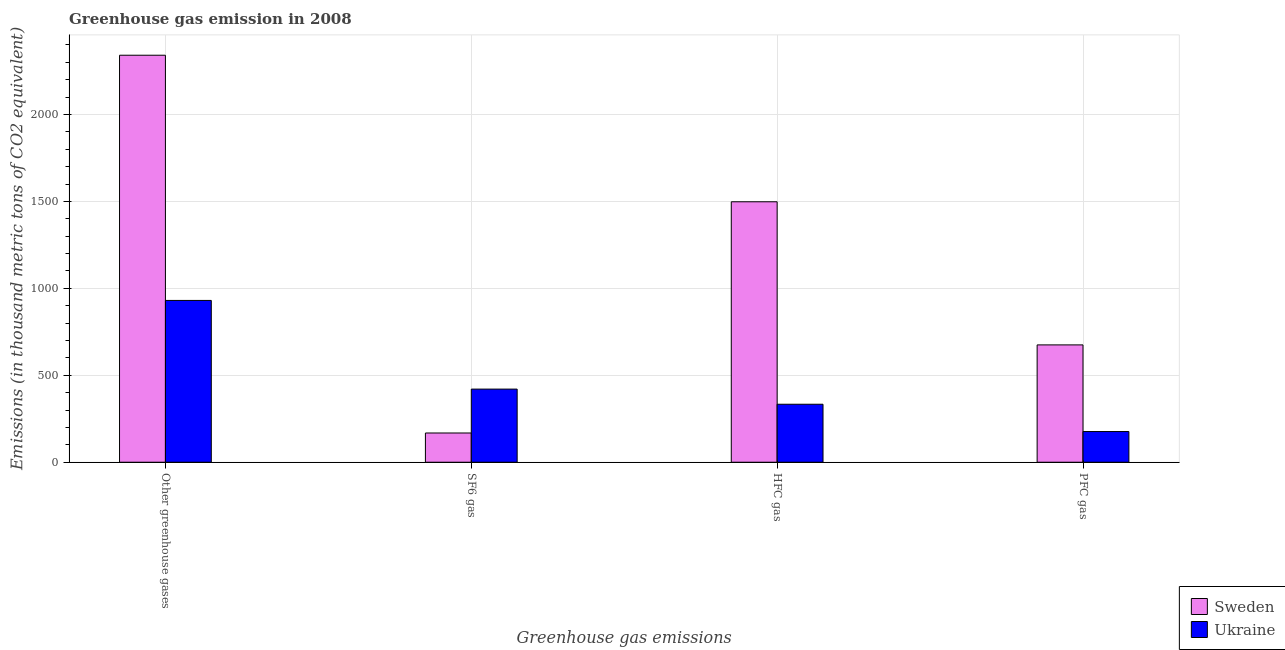How many groups of bars are there?
Your response must be concise. 4. Are the number of bars per tick equal to the number of legend labels?
Your response must be concise. Yes. How many bars are there on the 1st tick from the left?
Offer a terse response. 2. How many bars are there on the 3rd tick from the right?
Keep it short and to the point. 2. What is the label of the 4th group of bars from the left?
Make the answer very short. PFC gas. What is the emission of sf6 gas in Sweden?
Provide a succinct answer. 168.1. Across all countries, what is the maximum emission of pfc gas?
Your answer should be compact. 674.8. Across all countries, what is the minimum emission of greenhouse gases?
Ensure brevity in your answer.  930.6. In which country was the emission of pfc gas minimum?
Ensure brevity in your answer.  Ukraine. What is the total emission of greenhouse gases in the graph?
Ensure brevity in your answer.  3271.5. What is the difference between the emission of pfc gas in Sweden and that in Ukraine?
Offer a terse response. 498.3. What is the difference between the emission of pfc gas in Sweden and the emission of sf6 gas in Ukraine?
Your response must be concise. 254.2. What is the average emission of greenhouse gases per country?
Your response must be concise. 1635.75. What is the difference between the emission of hfc gas and emission of greenhouse gases in Sweden?
Your answer should be very brief. -842.9. In how many countries, is the emission of sf6 gas greater than 1000 thousand metric tons?
Your answer should be compact. 0. What is the ratio of the emission of hfc gas in Ukraine to that in Sweden?
Offer a very short reply. 0.22. Is the emission of pfc gas in Ukraine less than that in Sweden?
Give a very brief answer. Yes. Is the difference between the emission of greenhouse gases in Sweden and Ukraine greater than the difference between the emission of hfc gas in Sweden and Ukraine?
Provide a short and direct response. Yes. What is the difference between the highest and the second highest emission of hfc gas?
Your response must be concise. 1164.5. What is the difference between the highest and the lowest emission of sf6 gas?
Ensure brevity in your answer.  252.5. In how many countries, is the emission of hfc gas greater than the average emission of hfc gas taken over all countries?
Keep it short and to the point. 1. Is the sum of the emission of pfc gas in Sweden and Ukraine greater than the maximum emission of greenhouse gases across all countries?
Your response must be concise. No. Is it the case that in every country, the sum of the emission of greenhouse gases and emission of hfc gas is greater than the sum of emission of sf6 gas and emission of pfc gas?
Ensure brevity in your answer.  No. What does the 1st bar from the right in SF6 gas represents?
Ensure brevity in your answer.  Ukraine. Is it the case that in every country, the sum of the emission of greenhouse gases and emission of sf6 gas is greater than the emission of hfc gas?
Provide a succinct answer. Yes. Are all the bars in the graph horizontal?
Make the answer very short. No. How many countries are there in the graph?
Keep it short and to the point. 2. What is the difference between two consecutive major ticks on the Y-axis?
Keep it short and to the point. 500. Are the values on the major ticks of Y-axis written in scientific E-notation?
Your response must be concise. No. How many legend labels are there?
Offer a terse response. 2. How are the legend labels stacked?
Your response must be concise. Vertical. What is the title of the graph?
Ensure brevity in your answer.  Greenhouse gas emission in 2008. What is the label or title of the X-axis?
Your answer should be compact. Greenhouse gas emissions. What is the label or title of the Y-axis?
Provide a short and direct response. Emissions (in thousand metric tons of CO2 equivalent). What is the Emissions (in thousand metric tons of CO2 equivalent) of Sweden in Other greenhouse gases?
Keep it short and to the point. 2340.9. What is the Emissions (in thousand metric tons of CO2 equivalent) in Ukraine in Other greenhouse gases?
Give a very brief answer. 930.6. What is the Emissions (in thousand metric tons of CO2 equivalent) of Sweden in SF6 gas?
Your answer should be compact. 168.1. What is the Emissions (in thousand metric tons of CO2 equivalent) in Ukraine in SF6 gas?
Offer a very short reply. 420.6. What is the Emissions (in thousand metric tons of CO2 equivalent) in Sweden in HFC gas?
Give a very brief answer. 1498. What is the Emissions (in thousand metric tons of CO2 equivalent) in Ukraine in HFC gas?
Offer a very short reply. 333.5. What is the Emissions (in thousand metric tons of CO2 equivalent) of Sweden in PFC gas?
Ensure brevity in your answer.  674.8. What is the Emissions (in thousand metric tons of CO2 equivalent) in Ukraine in PFC gas?
Make the answer very short. 176.5. Across all Greenhouse gas emissions, what is the maximum Emissions (in thousand metric tons of CO2 equivalent) of Sweden?
Your answer should be compact. 2340.9. Across all Greenhouse gas emissions, what is the maximum Emissions (in thousand metric tons of CO2 equivalent) of Ukraine?
Offer a terse response. 930.6. Across all Greenhouse gas emissions, what is the minimum Emissions (in thousand metric tons of CO2 equivalent) in Sweden?
Provide a short and direct response. 168.1. Across all Greenhouse gas emissions, what is the minimum Emissions (in thousand metric tons of CO2 equivalent) in Ukraine?
Your answer should be compact. 176.5. What is the total Emissions (in thousand metric tons of CO2 equivalent) of Sweden in the graph?
Keep it short and to the point. 4681.8. What is the total Emissions (in thousand metric tons of CO2 equivalent) in Ukraine in the graph?
Give a very brief answer. 1861.2. What is the difference between the Emissions (in thousand metric tons of CO2 equivalent) of Sweden in Other greenhouse gases and that in SF6 gas?
Your answer should be compact. 2172.8. What is the difference between the Emissions (in thousand metric tons of CO2 equivalent) in Ukraine in Other greenhouse gases and that in SF6 gas?
Your answer should be very brief. 510. What is the difference between the Emissions (in thousand metric tons of CO2 equivalent) in Sweden in Other greenhouse gases and that in HFC gas?
Provide a short and direct response. 842.9. What is the difference between the Emissions (in thousand metric tons of CO2 equivalent) in Ukraine in Other greenhouse gases and that in HFC gas?
Keep it short and to the point. 597.1. What is the difference between the Emissions (in thousand metric tons of CO2 equivalent) in Sweden in Other greenhouse gases and that in PFC gas?
Make the answer very short. 1666.1. What is the difference between the Emissions (in thousand metric tons of CO2 equivalent) in Ukraine in Other greenhouse gases and that in PFC gas?
Offer a very short reply. 754.1. What is the difference between the Emissions (in thousand metric tons of CO2 equivalent) in Sweden in SF6 gas and that in HFC gas?
Offer a terse response. -1329.9. What is the difference between the Emissions (in thousand metric tons of CO2 equivalent) of Ukraine in SF6 gas and that in HFC gas?
Make the answer very short. 87.1. What is the difference between the Emissions (in thousand metric tons of CO2 equivalent) in Sweden in SF6 gas and that in PFC gas?
Your answer should be compact. -506.7. What is the difference between the Emissions (in thousand metric tons of CO2 equivalent) in Ukraine in SF6 gas and that in PFC gas?
Offer a very short reply. 244.1. What is the difference between the Emissions (in thousand metric tons of CO2 equivalent) in Sweden in HFC gas and that in PFC gas?
Provide a short and direct response. 823.2. What is the difference between the Emissions (in thousand metric tons of CO2 equivalent) of Ukraine in HFC gas and that in PFC gas?
Keep it short and to the point. 157. What is the difference between the Emissions (in thousand metric tons of CO2 equivalent) of Sweden in Other greenhouse gases and the Emissions (in thousand metric tons of CO2 equivalent) of Ukraine in SF6 gas?
Offer a terse response. 1920.3. What is the difference between the Emissions (in thousand metric tons of CO2 equivalent) in Sweden in Other greenhouse gases and the Emissions (in thousand metric tons of CO2 equivalent) in Ukraine in HFC gas?
Give a very brief answer. 2007.4. What is the difference between the Emissions (in thousand metric tons of CO2 equivalent) in Sweden in Other greenhouse gases and the Emissions (in thousand metric tons of CO2 equivalent) in Ukraine in PFC gas?
Keep it short and to the point. 2164.4. What is the difference between the Emissions (in thousand metric tons of CO2 equivalent) in Sweden in SF6 gas and the Emissions (in thousand metric tons of CO2 equivalent) in Ukraine in HFC gas?
Offer a terse response. -165.4. What is the difference between the Emissions (in thousand metric tons of CO2 equivalent) in Sweden in SF6 gas and the Emissions (in thousand metric tons of CO2 equivalent) in Ukraine in PFC gas?
Keep it short and to the point. -8.4. What is the difference between the Emissions (in thousand metric tons of CO2 equivalent) of Sweden in HFC gas and the Emissions (in thousand metric tons of CO2 equivalent) of Ukraine in PFC gas?
Offer a terse response. 1321.5. What is the average Emissions (in thousand metric tons of CO2 equivalent) of Sweden per Greenhouse gas emissions?
Ensure brevity in your answer.  1170.45. What is the average Emissions (in thousand metric tons of CO2 equivalent) of Ukraine per Greenhouse gas emissions?
Offer a terse response. 465.3. What is the difference between the Emissions (in thousand metric tons of CO2 equivalent) in Sweden and Emissions (in thousand metric tons of CO2 equivalent) in Ukraine in Other greenhouse gases?
Provide a short and direct response. 1410.3. What is the difference between the Emissions (in thousand metric tons of CO2 equivalent) in Sweden and Emissions (in thousand metric tons of CO2 equivalent) in Ukraine in SF6 gas?
Provide a succinct answer. -252.5. What is the difference between the Emissions (in thousand metric tons of CO2 equivalent) of Sweden and Emissions (in thousand metric tons of CO2 equivalent) of Ukraine in HFC gas?
Your answer should be compact. 1164.5. What is the difference between the Emissions (in thousand metric tons of CO2 equivalent) in Sweden and Emissions (in thousand metric tons of CO2 equivalent) in Ukraine in PFC gas?
Keep it short and to the point. 498.3. What is the ratio of the Emissions (in thousand metric tons of CO2 equivalent) in Sweden in Other greenhouse gases to that in SF6 gas?
Give a very brief answer. 13.93. What is the ratio of the Emissions (in thousand metric tons of CO2 equivalent) in Ukraine in Other greenhouse gases to that in SF6 gas?
Your answer should be compact. 2.21. What is the ratio of the Emissions (in thousand metric tons of CO2 equivalent) in Sweden in Other greenhouse gases to that in HFC gas?
Ensure brevity in your answer.  1.56. What is the ratio of the Emissions (in thousand metric tons of CO2 equivalent) in Ukraine in Other greenhouse gases to that in HFC gas?
Keep it short and to the point. 2.79. What is the ratio of the Emissions (in thousand metric tons of CO2 equivalent) in Sweden in Other greenhouse gases to that in PFC gas?
Ensure brevity in your answer.  3.47. What is the ratio of the Emissions (in thousand metric tons of CO2 equivalent) of Ukraine in Other greenhouse gases to that in PFC gas?
Provide a short and direct response. 5.27. What is the ratio of the Emissions (in thousand metric tons of CO2 equivalent) of Sweden in SF6 gas to that in HFC gas?
Keep it short and to the point. 0.11. What is the ratio of the Emissions (in thousand metric tons of CO2 equivalent) of Ukraine in SF6 gas to that in HFC gas?
Offer a very short reply. 1.26. What is the ratio of the Emissions (in thousand metric tons of CO2 equivalent) in Sweden in SF6 gas to that in PFC gas?
Provide a succinct answer. 0.25. What is the ratio of the Emissions (in thousand metric tons of CO2 equivalent) in Ukraine in SF6 gas to that in PFC gas?
Ensure brevity in your answer.  2.38. What is the ratio of the Emissions (in thousand metric tons of CO2 equivalent) in Sweden in HFC gas to that in PFC gas?
Offer a terse response. 2.22. What is the ratio of the Emissions (in thousand metric tons of CO2 equivalent) in Ukraine in HFC gas to that in PFC gas?
Ensure brevity in your answer.  1.89. What is the difference between the highest and the second highest Emissions (in thousand metric tons of CO2 equivalent) in Sweden?
Provide a short and direct response. 842.9. What is the difference between the highest and the second highest Emissions (in thousand metric tons of CO2 equivalent) of Ukraine?
Provide a succinct answer. 510. What is the difference between the highest and the lowest Emissions (in thousand metric tons of CO2 equivalent) in Sweden?
Offer a very short reply. 2172.8. What is the difference between the highest and the lowest Emissions (in thousand metric tons of CO2 equivalent) in Ukraine?
Offer a terse response. 754.1. 